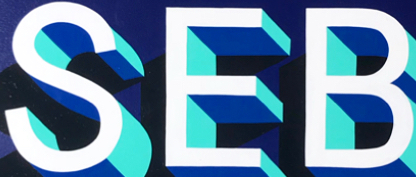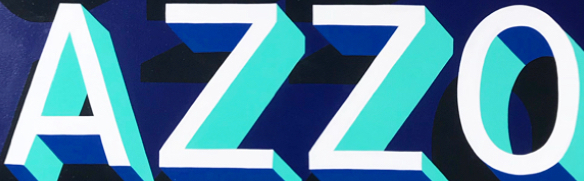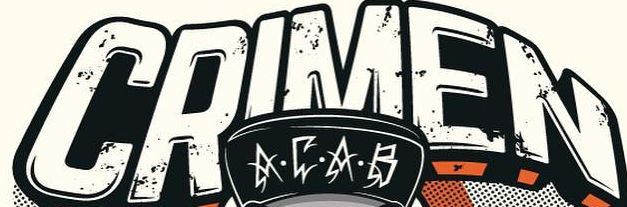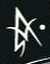Identify the words shown in these images in order, separated by a semicolon. SEB; AZZO; CRIMEN; A 